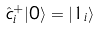<formula> <loc_0><loc_0><loc_500><loc_500>\hat { c } _ { i } ^ { + } | 0 \rangle = | 1 _ { i } \rangle</formula> 